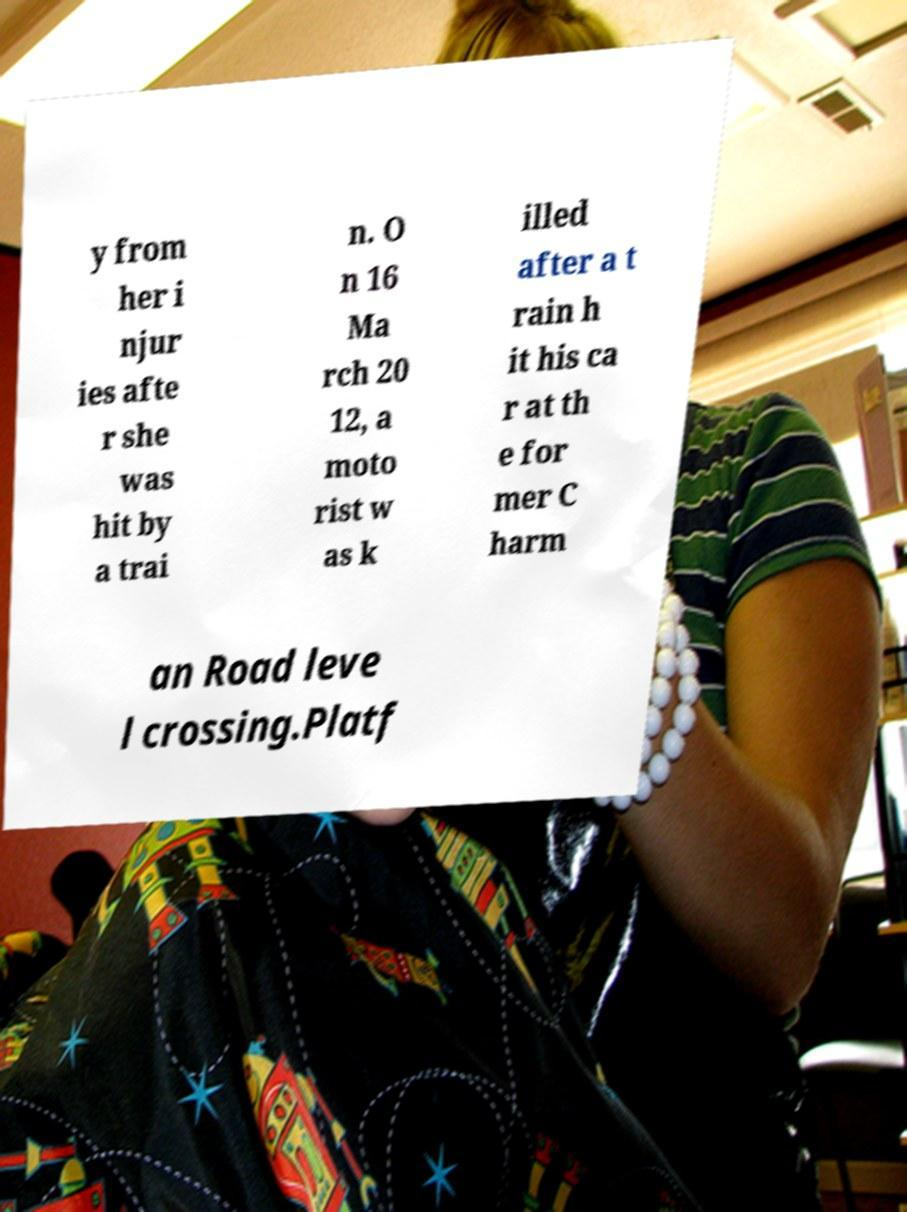I need the written content from this picture converted into text. Can you do that? y from her i njur ies afte r she was hit by a trai n. O n 16 Ma rch 20 12, a moto rist w as k illed after a t rain h it his ca r at th e for mer C harm an Road leve l crossing.Platf 